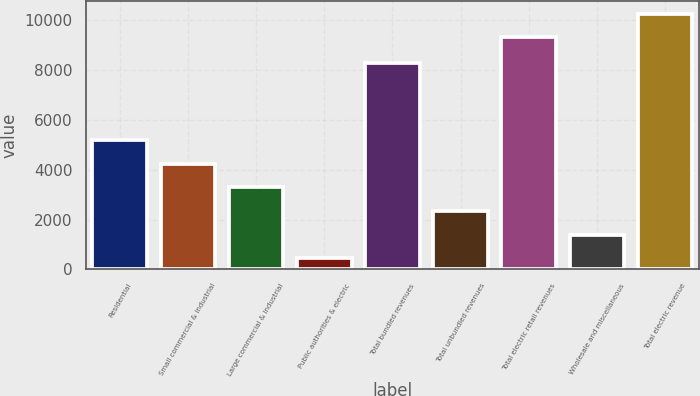<chart> <loc_0><loc_0><loc_500><loc_500><bar_chart><fcel>Residential<fcel>Small commercial & industrial<fcel>Large commercial & industrial<fcel>Public authorities & electric<fcel>Total bundled revenues<fcel>Total unbundled revenues<fcel>Total electric retail revenues<fcel>Wholesale and miscellaneous<fcel>Total electric revenue<nl><fcel>5182<fcel>4236.8<fcel>3291.6<fcel>456<fcel>8272<fcel>2346.4<fcel>9327<fcel>1401.2<fcel>10272.2<nl></chart> 